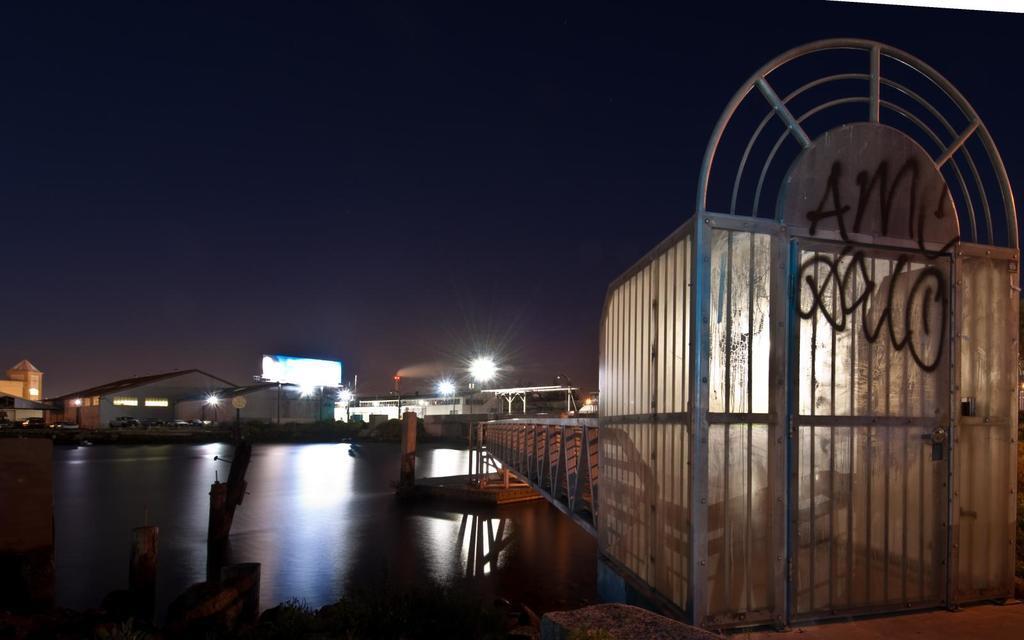How would you summarize this image in a sentence or two? In this picture we can see a gate with a door, here we can see a bridge, water and some objects and in the background we can see sheds, lights and the sky. 